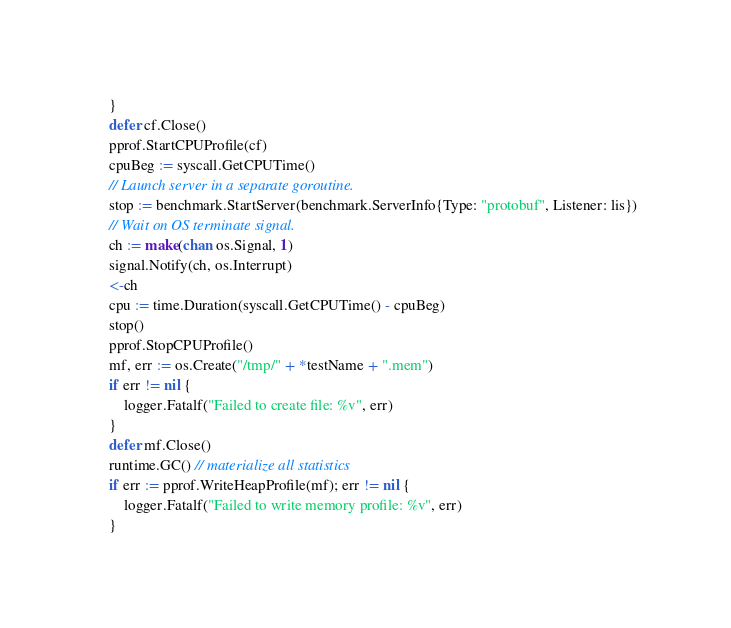<code> <loc_0><loc_0><loc_500><loc_500><_Go_>	}
	defer cf.Close()
	pprof.StartCPUProfile(cf)
	cpuBeg := syscall.GetCPUTime()
	// Launch server in a separate goroutine.
	stop := benchmark.StartServer(benchmark.ServerInfo{Type: "protobuf", Listener: lis})
	// Wait on OS terminate signal.
	ch := make(chan os.Signal, 1)
	signal.Notify(ch, os.Interrupt)
	<-ch
	cpu := time.Duration(syscall.GetCPUTime() - cpuBeg)
	stop()
	pprof.StopCPUProfile()
	mf, err := os.Create("/tmp/" + *testName + ".mem")
	if err != nil {
		logger.Fatalf("Failed to create file: %v", err)
	}
	defer mf.Close()
	runtime.GC() // materialize all statistics
	if err := pprof.WriteHeapProfile(mf); err != nil {
		logger.Fatalf("Failed to write memory profile: %v", err)
	}</code> 